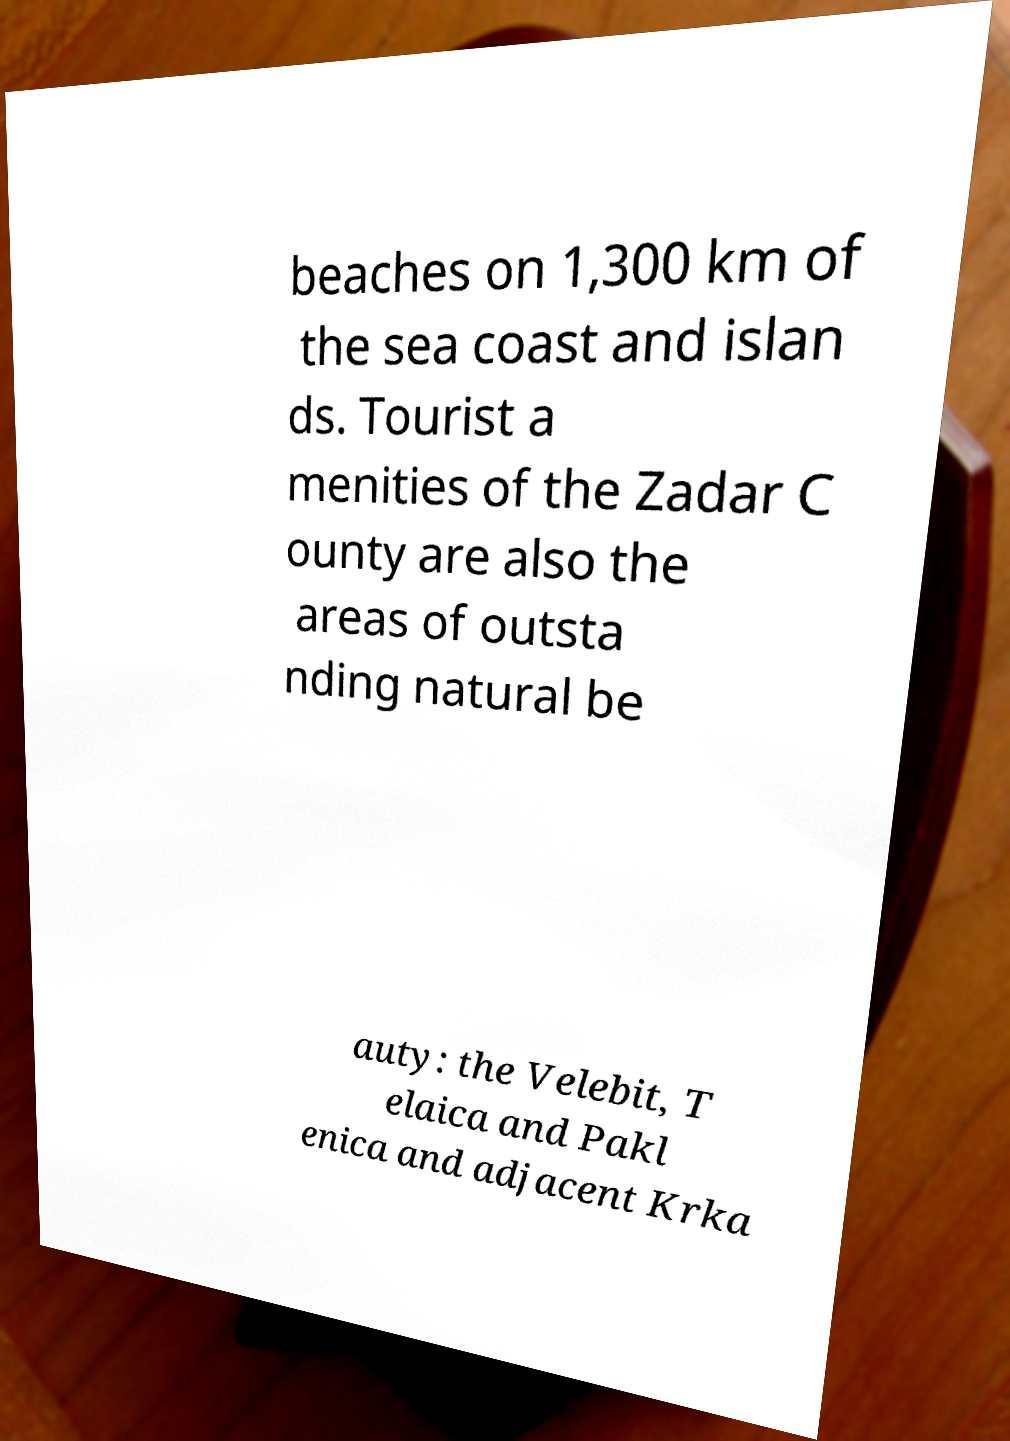Can you read and provide the text displayed in the image?This photo seems to have some interesting text. Can you extract and type it out for me? beaches on 1,300 km of the sea coast and islan ds. Tourist a menities of the Zadar C ounty are also the areas of outsta nding natural be auty: the Velebit, T elaica and Pakl enica and adjacent Krka 